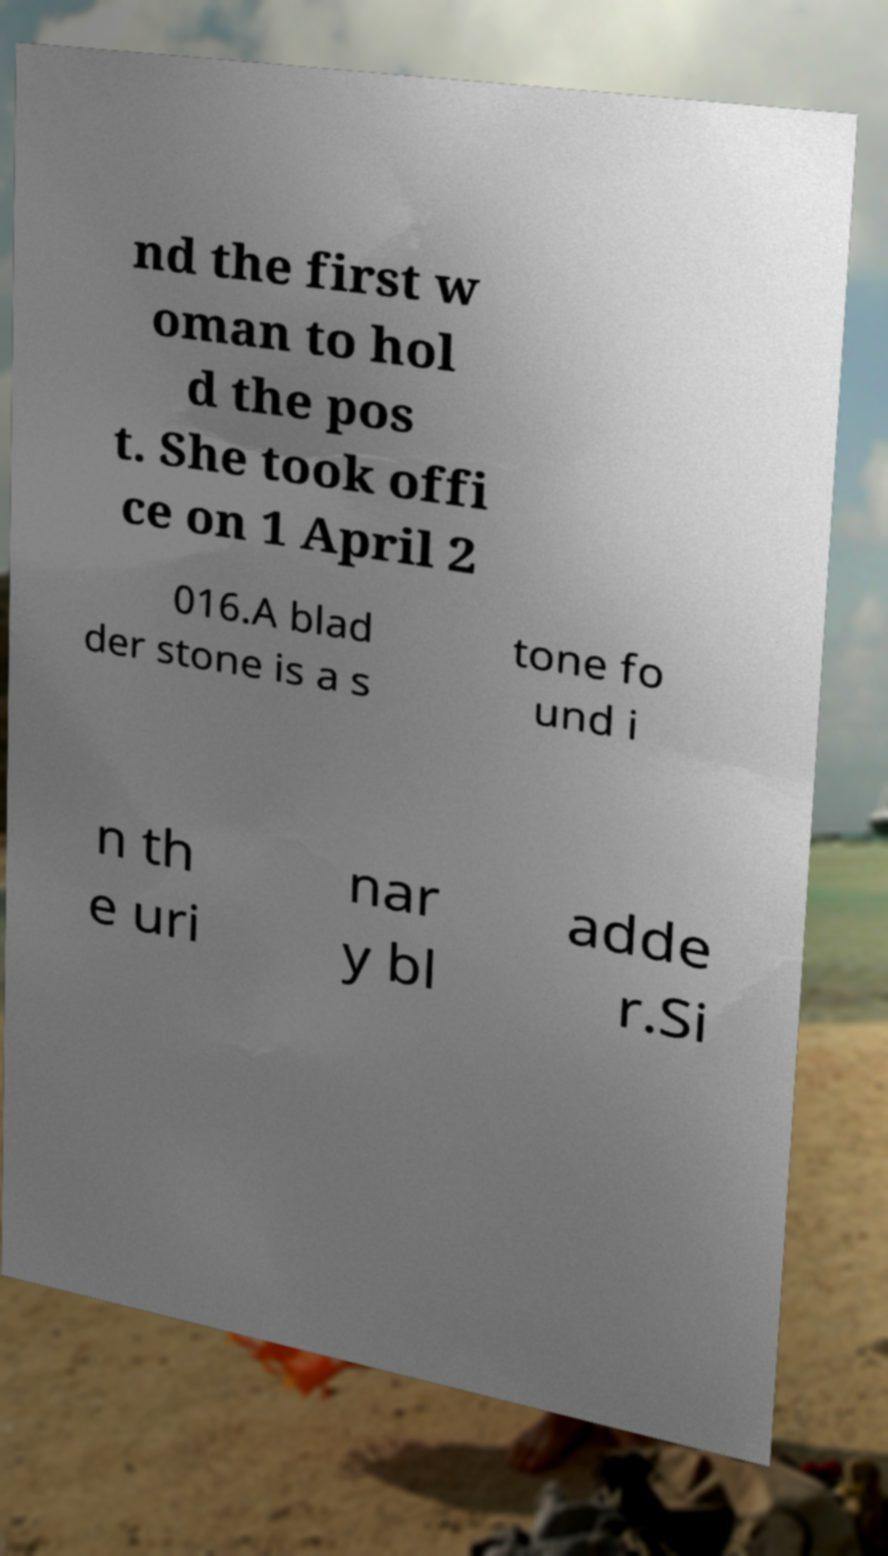For documentation purposes, I need the text within this image transcribed. Could you provide that? nd the first w oman to hol d the pos t. She took offi ce on 1 April 2 016.A blad der stone is a s tone fo und i n th e uri nar y bl adde r.Si 